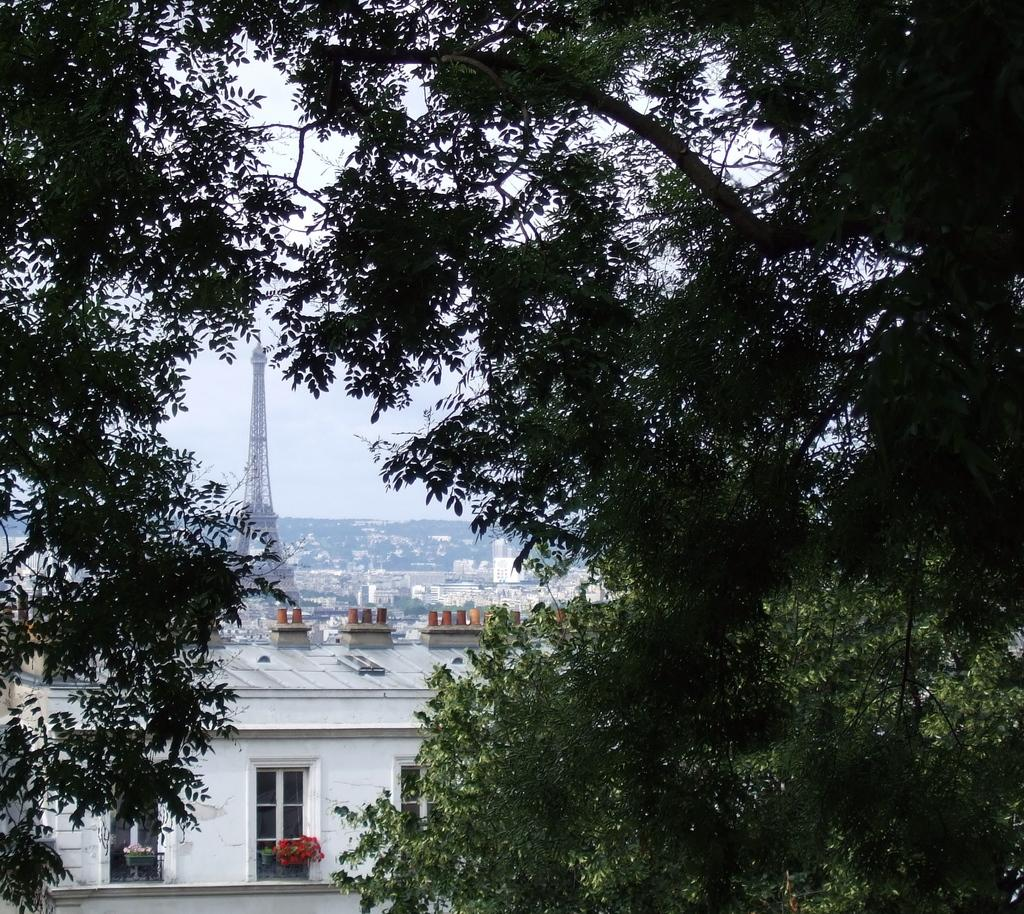What type of vegetation can be seen in the image? There are trees in the image. What structure is located on the left side of the image? There is a tower on the left side of the image. What type of man-made structures are present in the image? There are buildings in the image. What is visible in the background of the image? The sky is visible in the background of the image. How does the maid perform addition in the image? There is no maid present in the image, and therefore no such activity can be observed. What type of rub is visible on the trees in the image? There is no rub present on the trees in the image; they appear to be natural vegetation. 